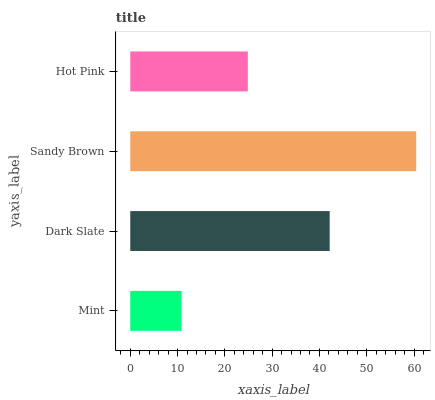Is Mint the minimum?
Answer yes or no. Yes. Is Sandy Brown the maximum?
Answer yes or no. Yes. Is Dark Slate the minimum?
Answer yes or no. No. Is Dark Slate the maximum?
Answer yes or no. No. Is Dark Slate greater than Mint?
Answer yes or no. Yes. Is Mint less than Dark Slate?
Answer yes or no. Yes. Is Mint greater than Dark Slate?
Answer yes or no. No. Is Dark Slate less than Mint?
Answer yes or no. No. Is Dark Slate the high median?
Answer yes or no. Yes. Is Hot Pink the low median?
Answer yes or no. Yes. Is Sandy Brown the high median?
Answer yes or no. No. Is Mint the low median?
Answer yes or no. No. 